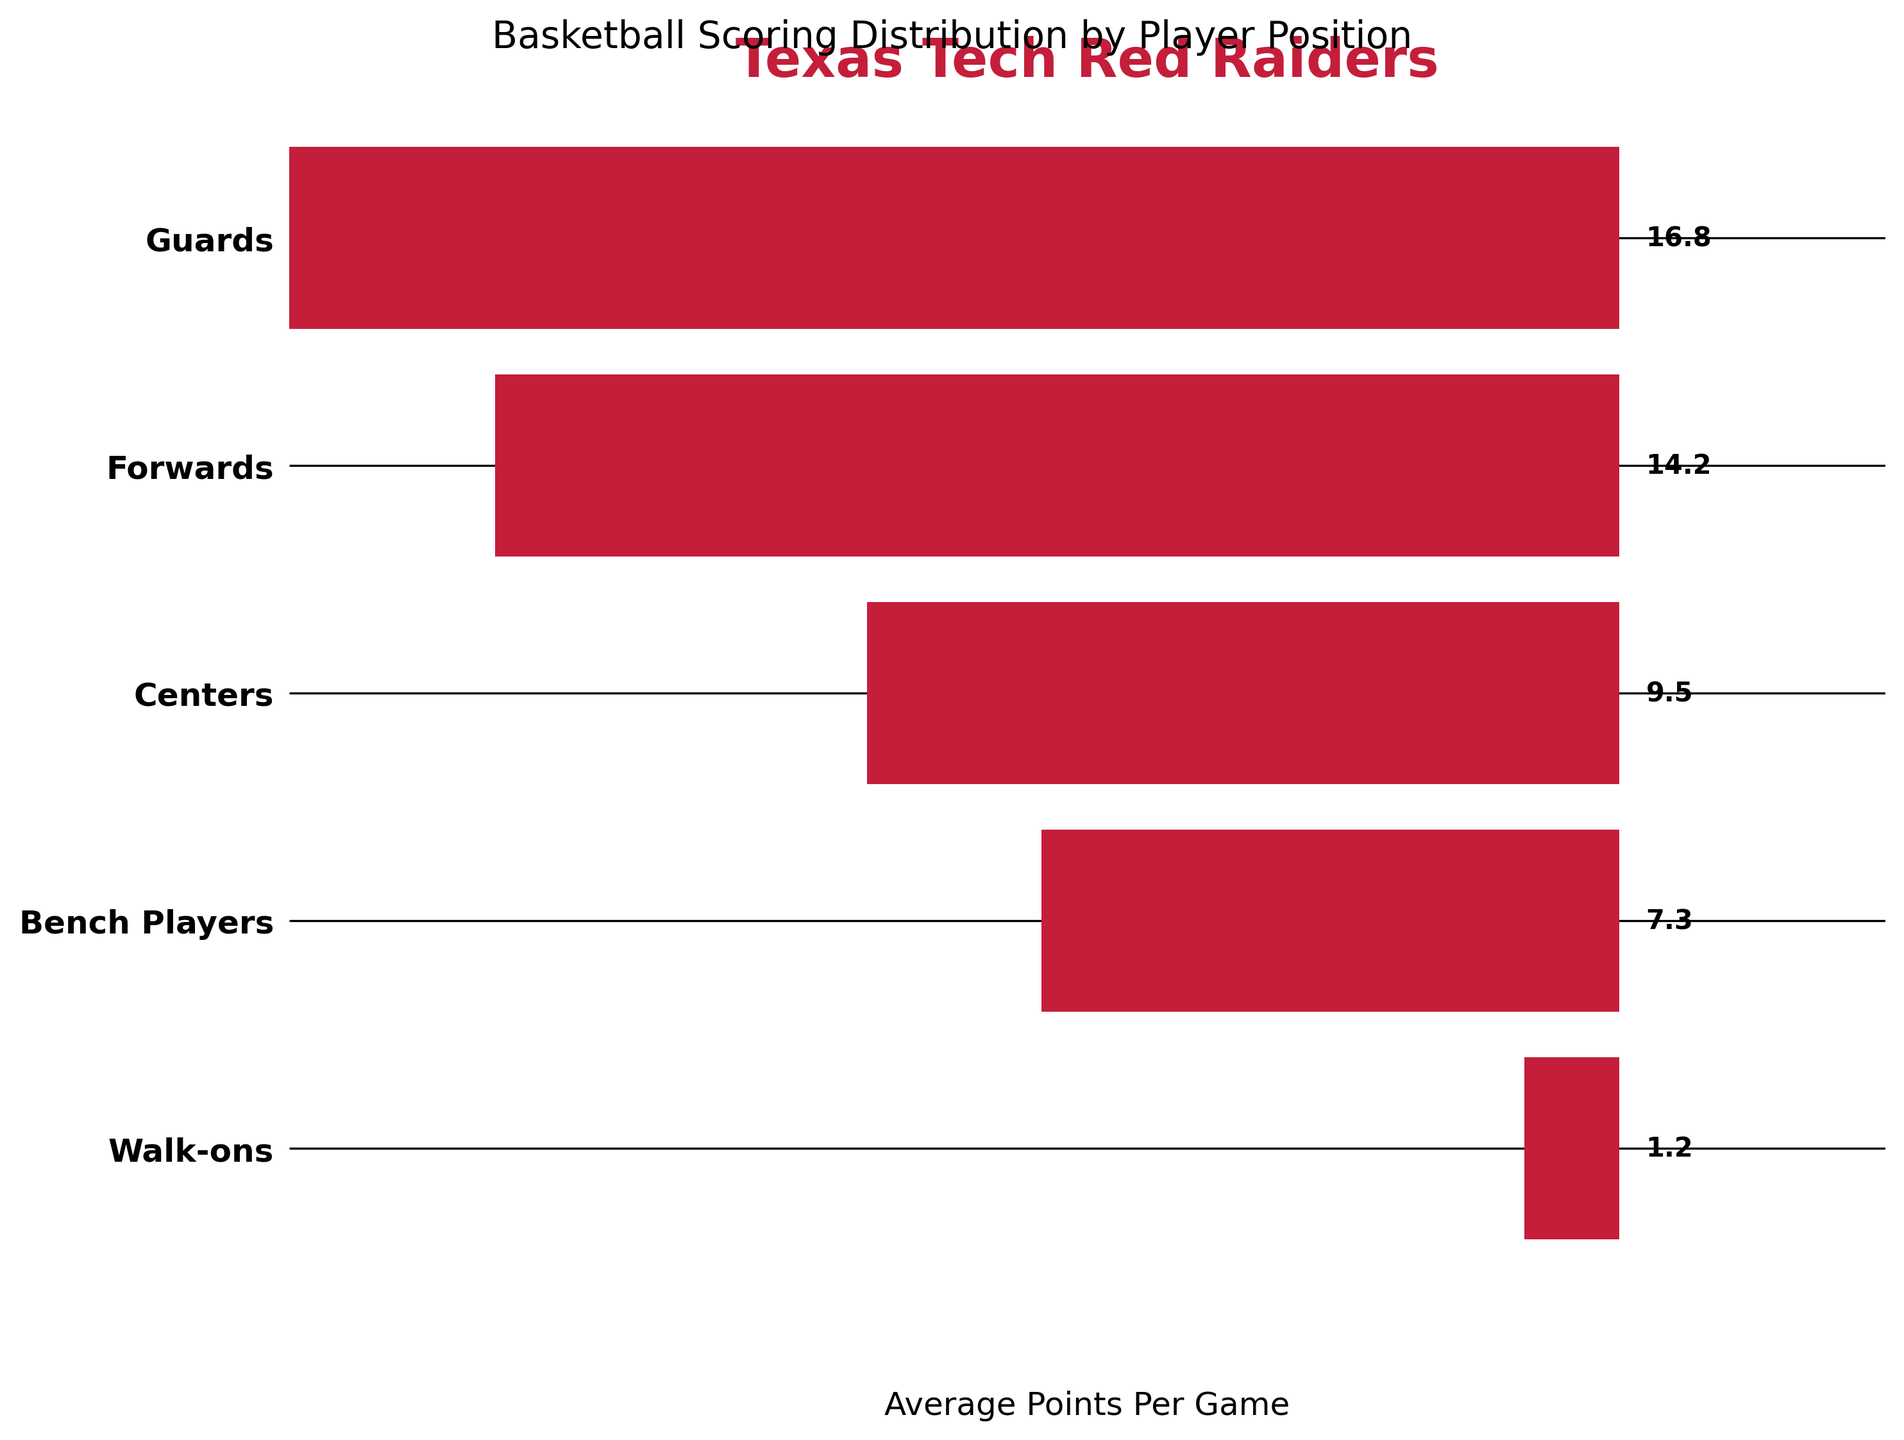What's the title of the figure? The title is located at the top and indicates the content of the figure.
Answer: Texas Tech Red Raiders What is the average points per game for Guards? The label next to the bar for Guards shows their average points per game.
Answer: 16.8 Which position scores the least average points per game? The smallest bar represents Walk-ons, and the label shows their average points.
Answer: Walk-ons How much more do Guards score on average compared to Centers? Subtract the average points of Centers from that of Guards (16.8 - 9.5).
Answer: 7.3 What is the total average points per game for the main positions (Guards, Forwards, Centers)? Sum the average points per game for Guards, Forwards, and Centers (16.8 + 14.2 + 9.5).
Answer: 40.5 Between Guards and Forwards, which position scores closer to 20 points per game? Compare the average points per game for Guards and Forwards to 20. Guards score 16.8 while Forwards score 14.2, thus Guards are closer.
Answer: Guards How does the average points per game for Forwards compare to Bench Players? Forwards average 14.2 while Bench Players average 7.3, which means Forwards score more.
Answer: Forwards score more What proportion of the highest scoring position's average does the Center position's average represent? Divide the Centers' average points by the Guards' average points and multiply by 100 ((9.5 / 16.8) * 100).
Answer: 56.5% How many positions have an average points per game greater than 10? Identify positions with greater than 10 points per game (Guards and Forwards).
Answer: 2 Which position has an average points per game closest to the overall average? First, calculate the overall average, then compare each position to find the closest one. The overall average is (16.8 + 14.2 + 9.5 + 7.3 + 1.2) / 5 = 9.8, and Centers score 9.5, closest to 9.8.
Answer: Centers 